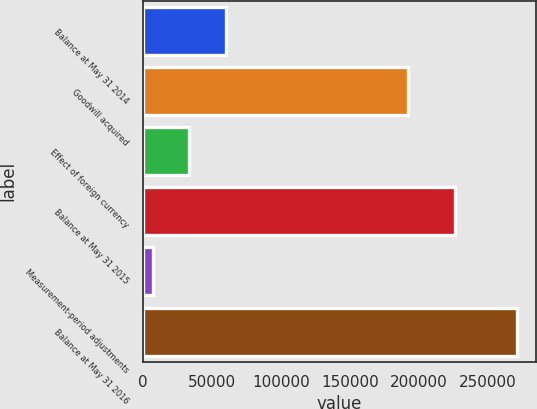Convert chart to OTSL. <chart><loc_0><loc_0><loc_500><loc_500><bar_chart><fcel>Balance at May 31 2014<fcel>Goodwill acquired<fcel>Effect of foreign currency<fcel>Balance at May 31 2015<fcel>Measurement-period adjustments<fcel>Balance at May 31 2016<nl><fcel>59855.6<fcel>192225<fcel>33437.3<fcel>226178<fcel>7019<fcel>271202<nl></chart> 